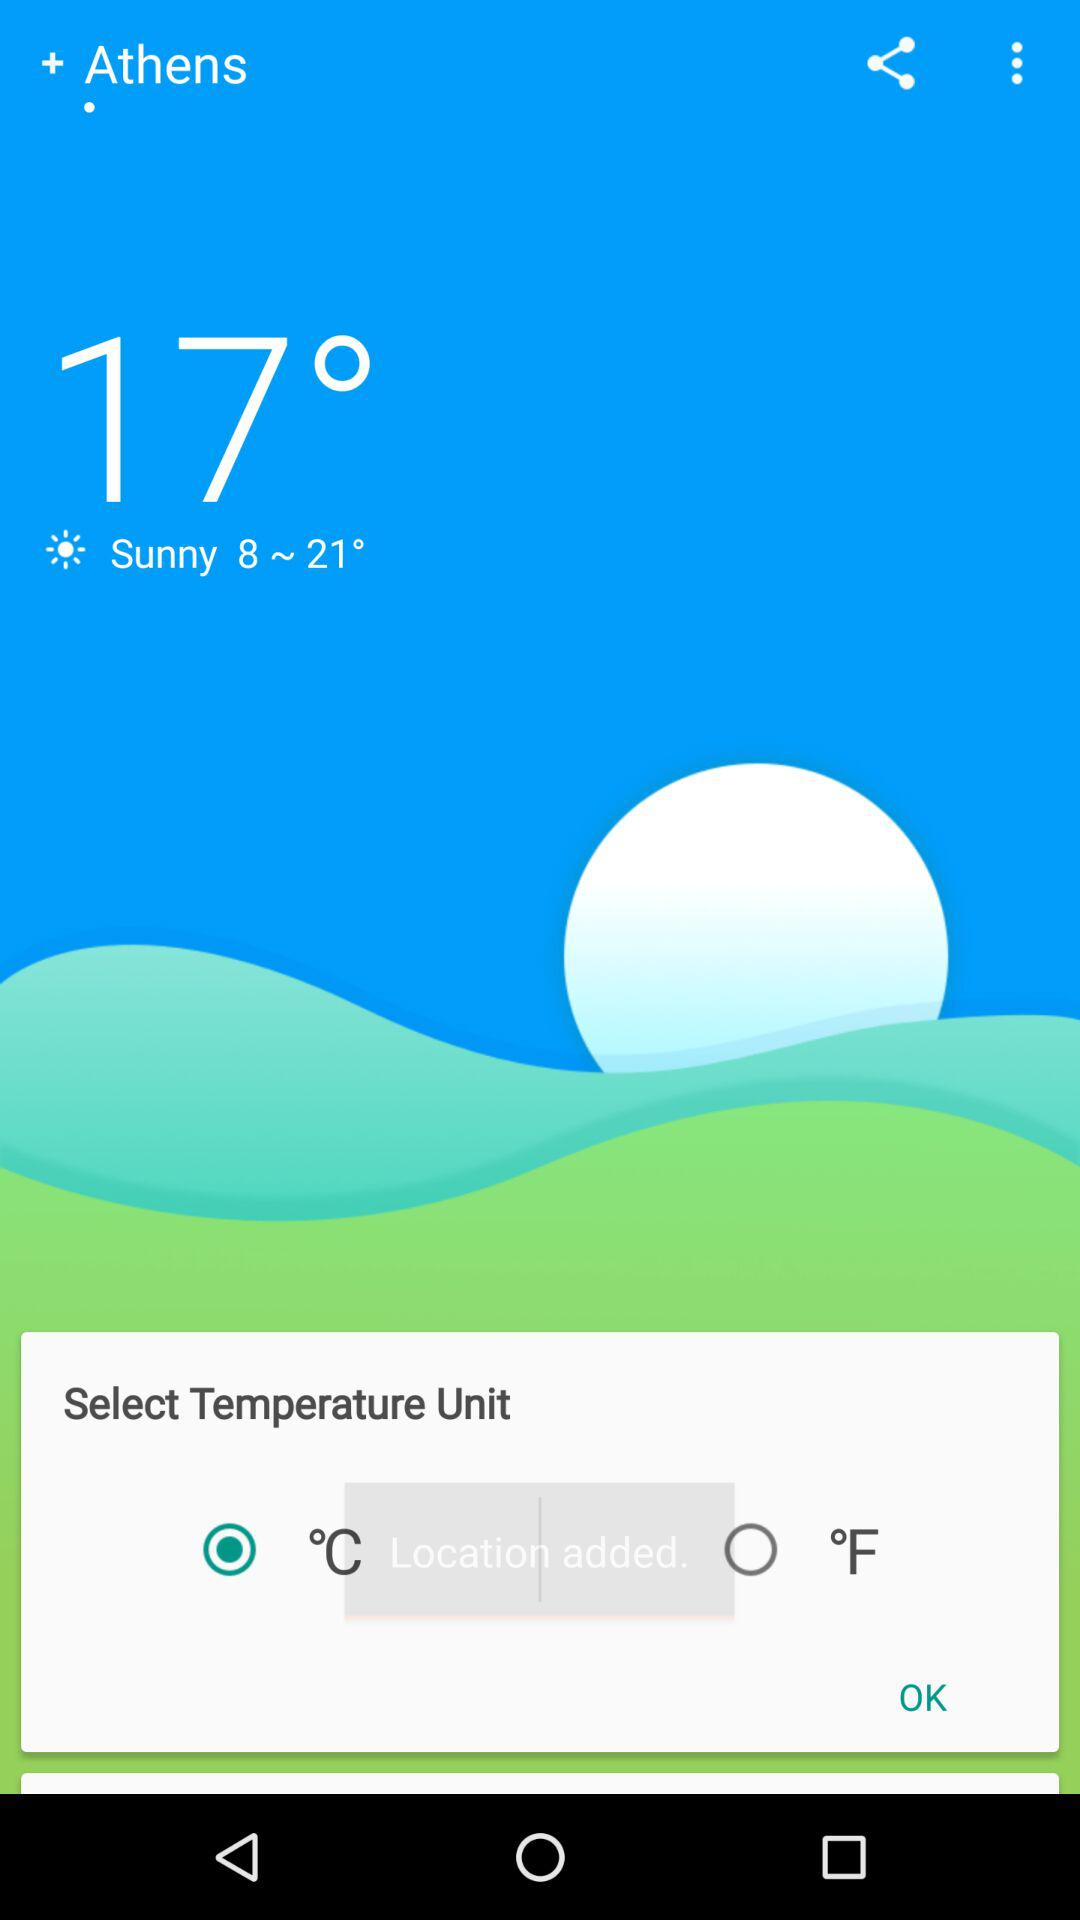What are the options for temperature units? The options for temperature units are degrees Celcius and degrees Fahrenheit. 